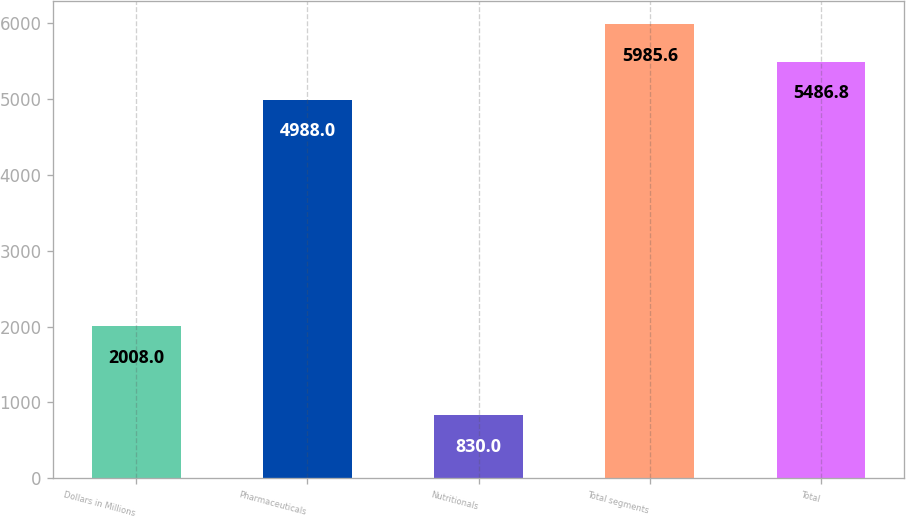Convert chart to OTSL. <chart><loc_0><loc_0><loc_500><loc_500><bar_chart><fcel>Dollars in Millions<fcel>Pharmaceuticals<fcel>Nutritionals<fcel>Total segments<fcel>Total<nl><fcel>2008<fcel>4988<fcel>830<fcel>5985.6<fcel>5486.8<nl></chart> 